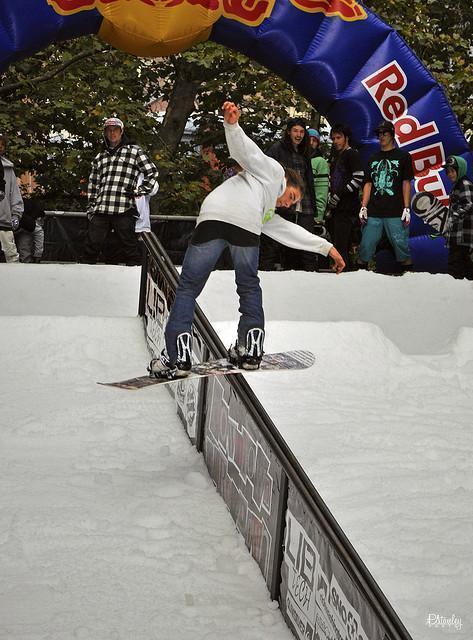What position does this player have the snowboards center point on the rail?
Answer the question by selecting the correct answer among the 4 following choices.
Options: Flat, parallel, right turn, curved. Flat. 